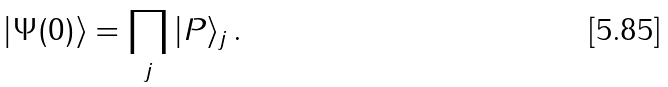<formula> <loc_0><loc_0><loc_500><loc_500>| \Psi ( 0 ) \rangle = \prod _ { j } | P \rangle _ { j } \, .</formula> 